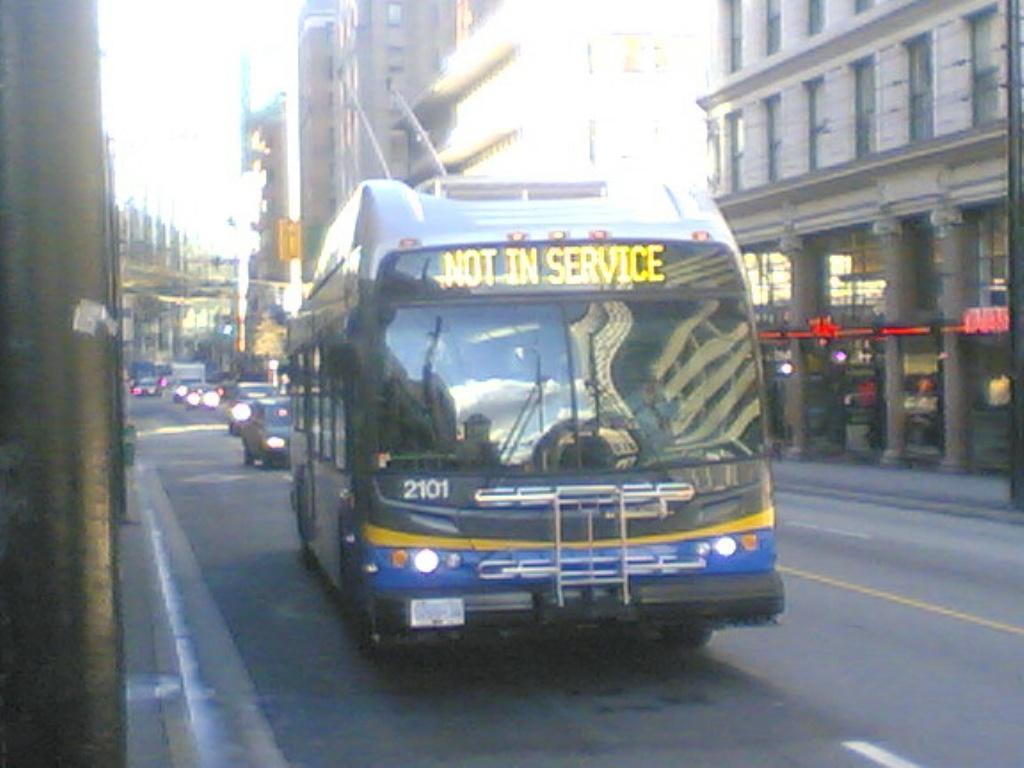How would you summarize this image in a sentence or two? In this image there are vehicles on the road. Beside the road there are poles. There are buildings and trees. 